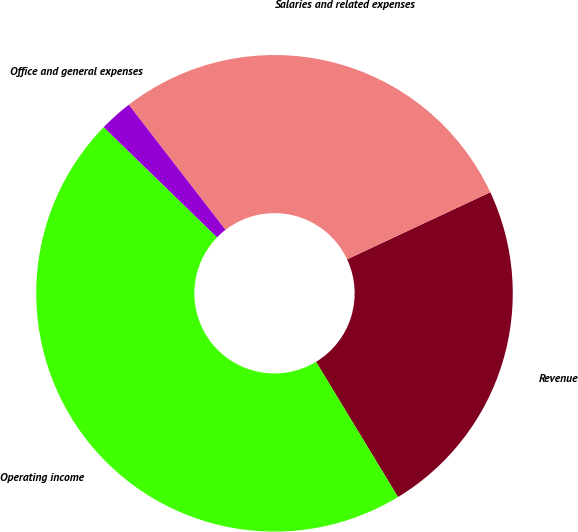<chart> <loc_0><loc_0><loc_500><loc_500><pie_chart><fcel>Revenue<fcel>Salaries and related expenses<fcel>Office and general expenses<fcel>Operating income<nl><fcel>23.3%<fcel>28.5%<fcel>2.26%<fcel>45.94%<nl></chart> 